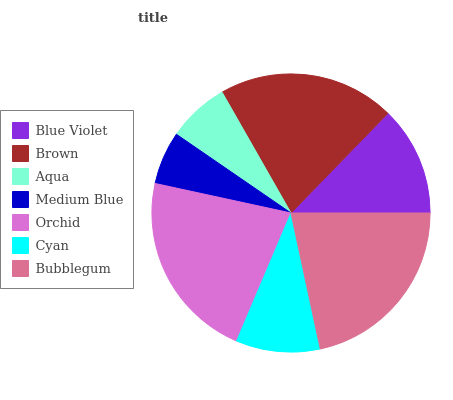Is Medium Blue the minimum?
Answer yes or no. Yes. Is Orchid the maximum?
Answer yes or no. Yes. Is Brown the minimum?
Answer yes or no. No. Is Brown the maximum?
Answer yes or no. No. Is Brown greater than Blue Violet?
Answer yes or no. Yes. Is Blue Violet less than Brown?
Answer yes or no. Yes. Is Blue Violet greater than Brown?
Answer yes or no. No. Is Brown less than Blue Violet?
Answer yes or no. No. Is Blue Violet the high median?
Answer yes or no. Yes. Is Blue Violet the low median?
Answer yes or no. Yes. Is Orchid the high median?
Answer yes or no. No. Is Brown the low median?
Answer yes or no. No. 